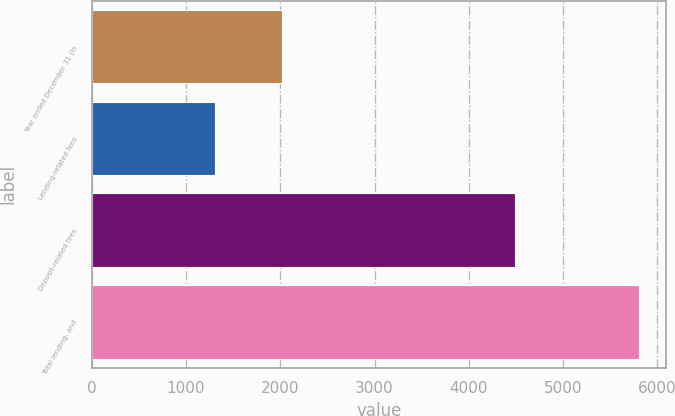Convert chart to OTSL. <chart><loc_0><loc_0><loc_500><loc_500><bar_chart><fcel>Year ended December 31 (in<fcel>Lending-related fees<fcel>Deposit-related fees<fcel>Total lending- and<nl><fcel>2014<fcel>1307<fcel>4494<fcel>5801<nl></chart> 